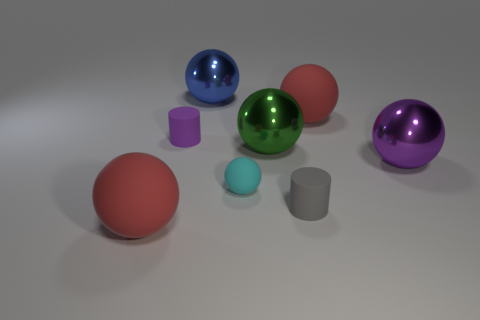Subtract all gray blocks. How many red balls are left? 2 Subtract 4 balls. How many balls are left? 2 Subtract all large green spheres. How many spheres are left? 5 Subtract all red balls. How many balls are left? 4 Add 1 balls. How many objects exist? 9 Subtract all red balls. Subtract all green cylinders. How many balls are left? 4 Subtract all spheres. How many objects are left? 2 Add 5 gray cylinders. How many gray cylinders are left? 6 Add 5 big brown metallic cubes. How many big brown metallic cubes exist? 5 Subtract 0 purple blocks. How many objects are left? 8 